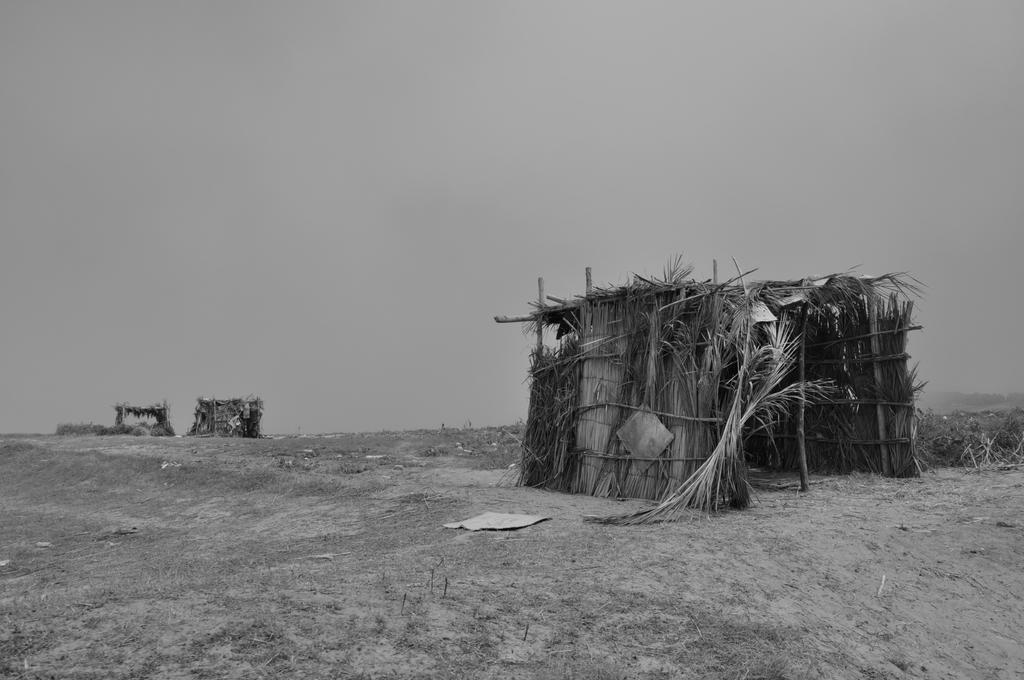What is the color scheme of the image? The image is black and white. What type of terrain can be seen in the image? There is land visible in the image. What type of structures are present in the image? There are huts in the image. What time of day is depicted in the image? The image is black and white, so it does not depict a specific time of day. Is there any evidence of a plough being used in the image? There is no plough visible in the image. 